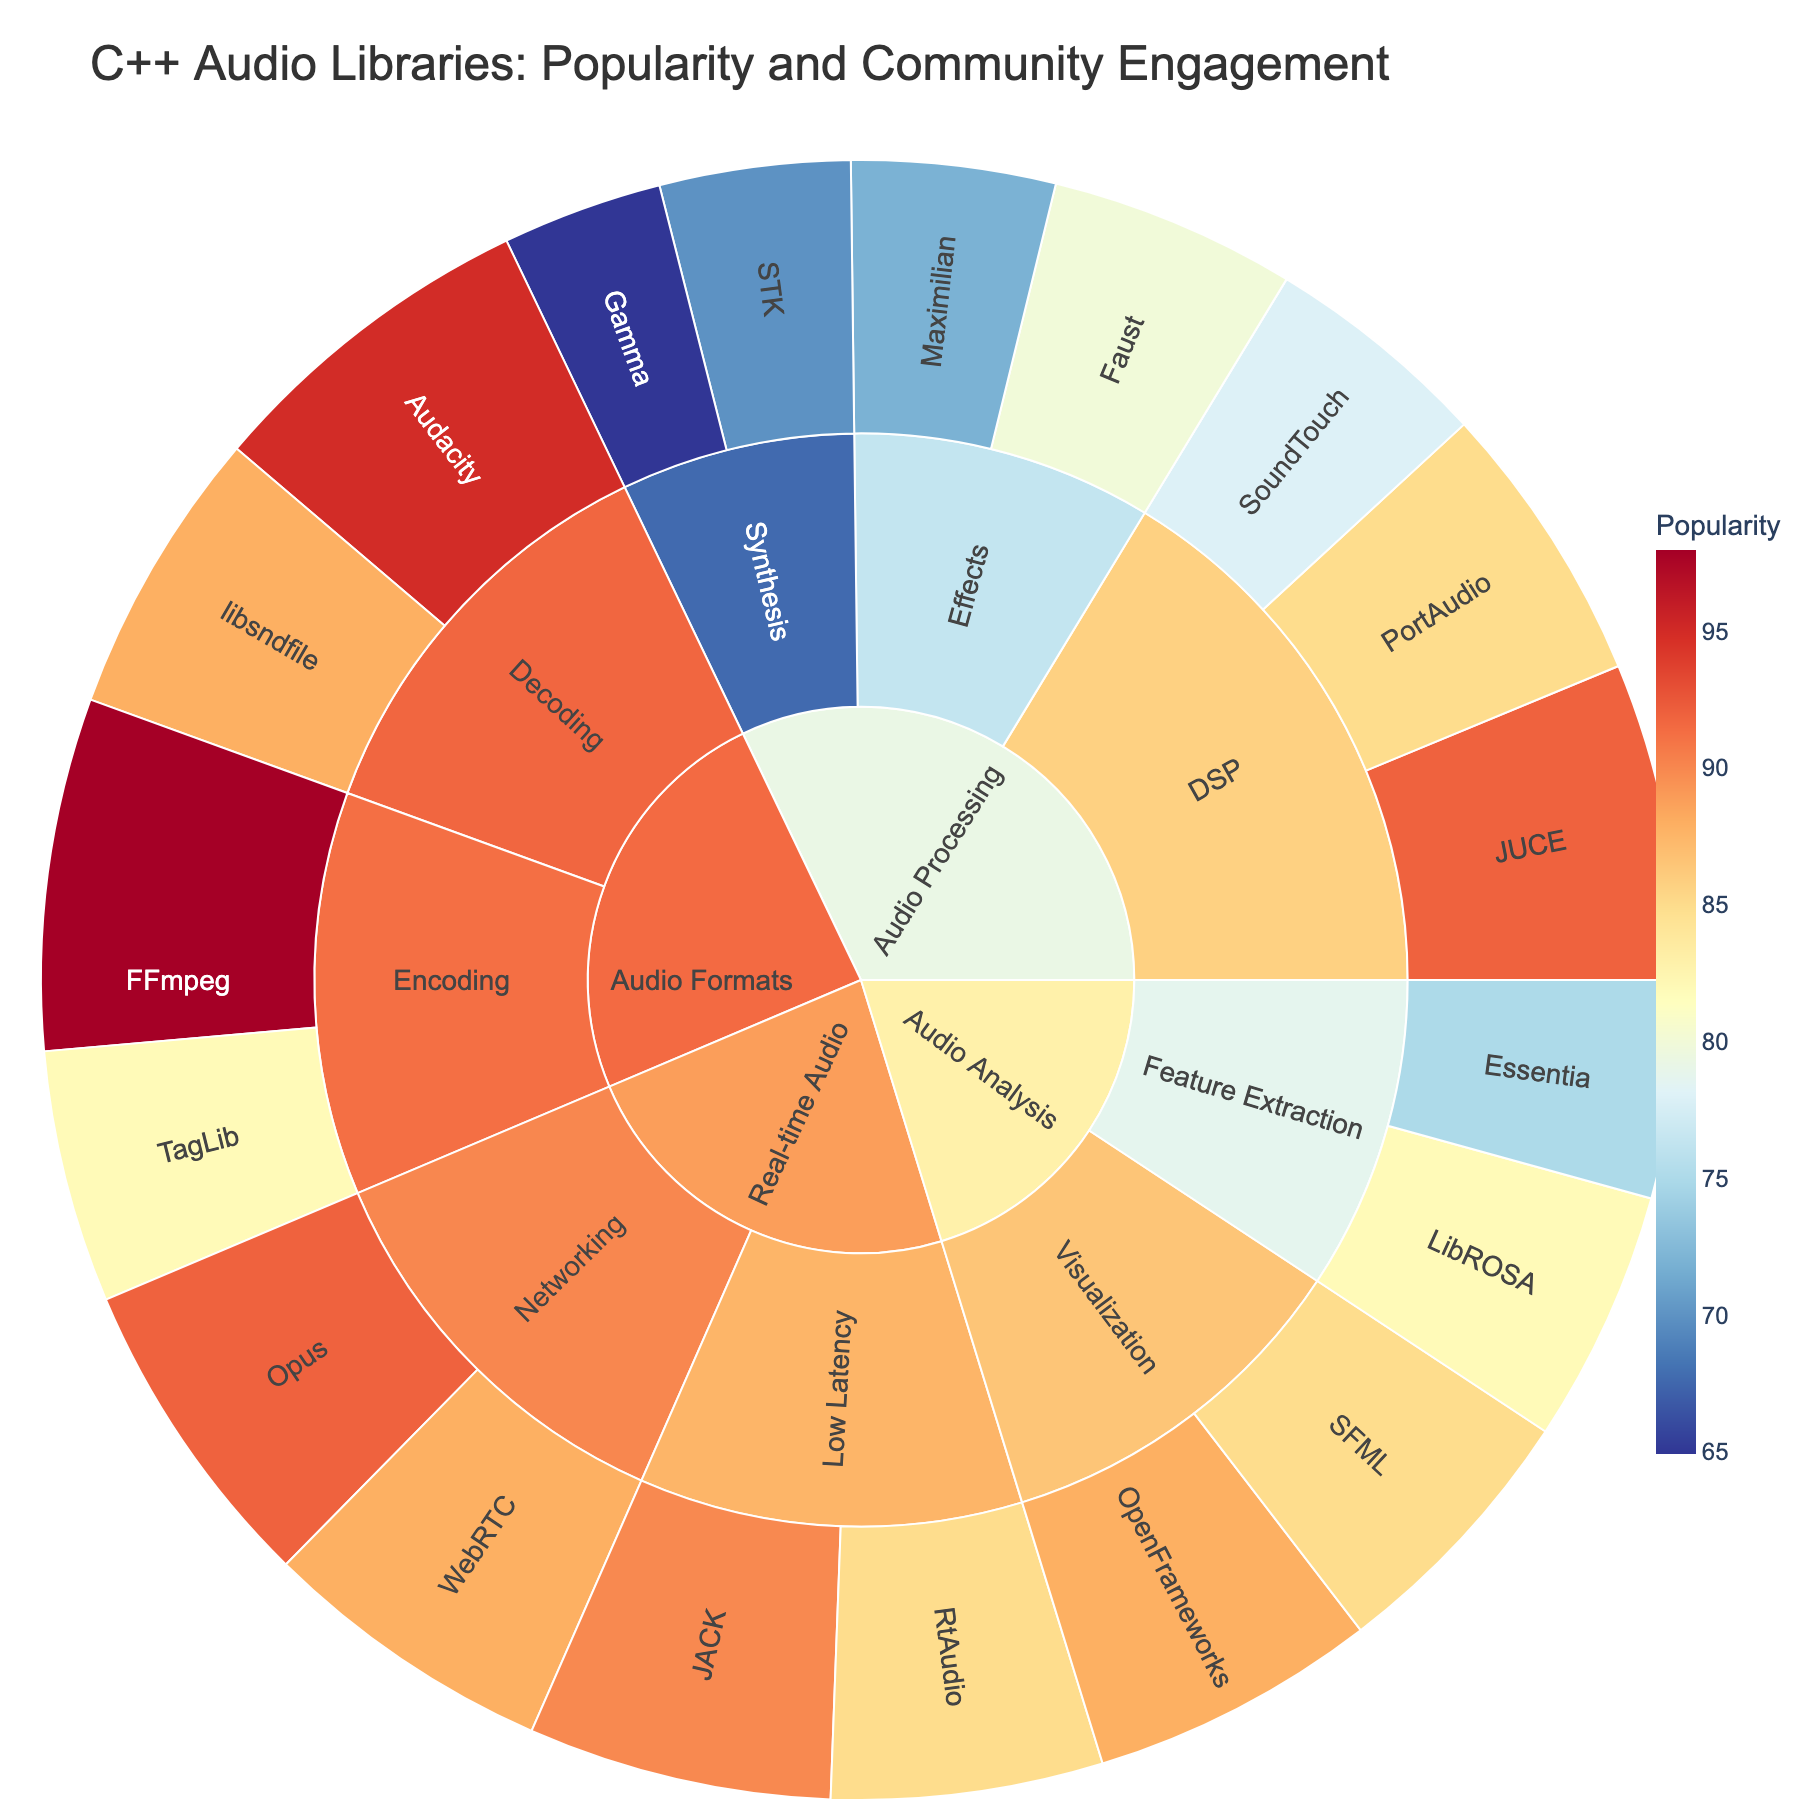How many categories are there in the sunburst plot? The sunburst plot visualizes data organized hierarchically with distinct segments for each category at the highest level. We observe individual sections labelled as "Audio Processing," "Audio Formats," "Real-time Audio," and "Audio Analysis," which totals four categories.
Answer: Four Which library has the highest popularity score? By examining the various segments under each category and looking for the segment with the highest numerical value in popularity, we find that FFmpeg, under "Audio Formats" > "Encoding," has the highest popularity score of 98.
Answer: FFmpeg What is the average community engagement for the Synthesis subcategory? The Synthesis subcategory has two libraries: STK with a community engagement of 75 and Gamma with 68. Adding these values gives 143. Dividing by the number of datapoints (2) gives 143/2 = 71.5.
Answer: 71.5 Which category has the highest combined value of popularity and community engagement? To determine this, we consider each category and sum the products of popularity and community engagement within them. Summarizing those products for all categories, "Audio Formats" has notable high-product libraries like FFmpeg, Audacity, leading to the highest total combined value.
Answer: Audio Formats How does WebRTC's popularity compare to Jack's? WebRTC, in "Real-time Audio" > "Networking," has a popularity of 88. JACK in "Real-time Audio" > "Low Latency," has a popularity of 90. 88 is slightly less than 90.
Answer: WebRTC is less popular than JACK What is the popularity difference between "libsndfile" and "OpenFrameworks"? Under "Audio Formats" > "Decoding," libsndfile has a popularity score of 88. "OpenFrameworks," under "Audio Analysis" > "Visualization," has a popularity score of 88. The difference is 88 - 88 = 0.
Answer: 0 Which has higher community engagement: PortAudio or JUCE? Under "Audio Processing" > "DSP", we compare PortAudio (92) and JUCE (95). JUCE's community engagement score is higher.
Answer: JUCE What is the combined popularity of libraries under "DSP" in "Audio Processing"? Adding the popularity scores of PortAudio (85), JUCE (92), and SoundTouch (78) yields 85 + 92 + 78 = 255.
Answer: 255 Compare the total number of libraries under "Audio Processing" to those under "Audio Formats." "Audio Processing" includes seven libraries (PortAudio, JUCE, SoundTouch, STK, Gamma, Faust, Maximilian), whereas "Audio Formats" includes four (libsndfile, Audacity, FFmpeg, TagLib).
Answer: Audio Processing has more libraries What is the most popular library in the "Synthesis" subcategory? Under "Audio Processing" > "Synthesis," comparing STK (popularity 70) and Gamma (popularity 65), STK has a higher popularity score.
Answer: STK 